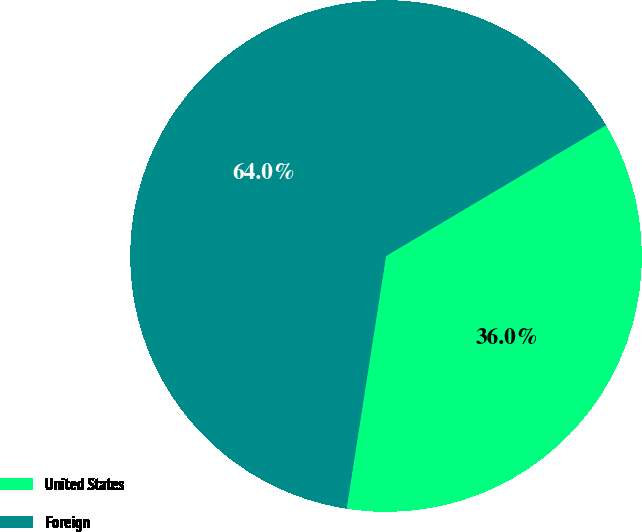Convert chart. <chart><loc_0><loc_0><loc_500><loc_500><pie_chart><fcel>United States<fcel>Foreign<nl><fcel>36.0%<fcel>64.0%<nl></chart> 